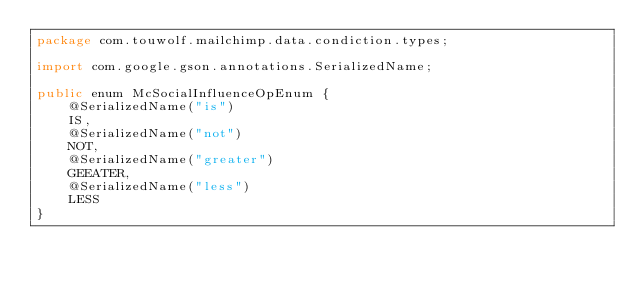<code> <loc_0><loc_0><loc_500><loc_500><_Java_>package com.touwolf.mailchimp.data.condiction.types;

import com.google.gson.annotations.SerializedName;

public enum McSocialInfluenceOpEnum {
    @SerializedName("is")
    IS,
    @SerializedName("not")
    NOT,
    @SerializedName("greater")
    GEEATER,
    @SerializedName("less")
    LESS
}
</code> 